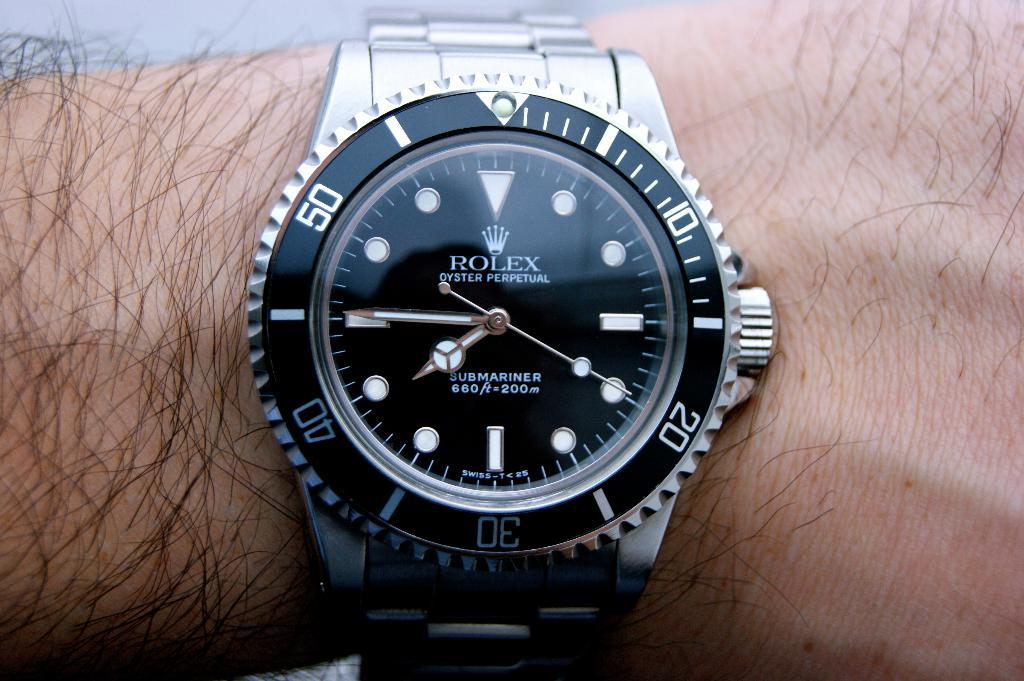<image>
Render a clear and concise summary of the photo. the word Rolex that is on a dark watch 